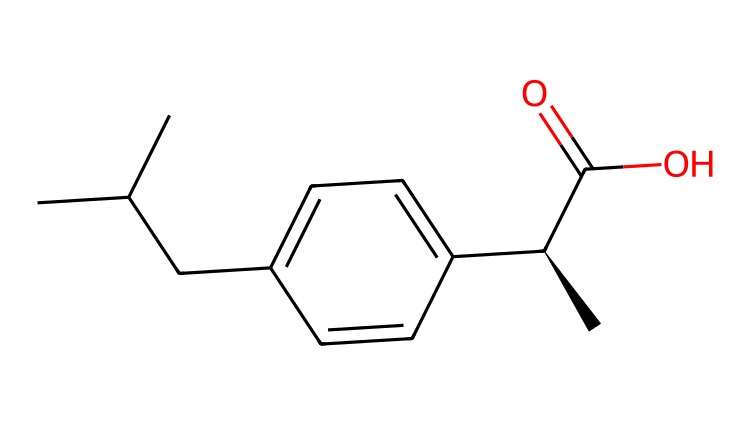What is the molecular formula of ibuprofen? By analyzing the SMILES representation (CC(C)Cc1ccc(cc1)[C@H](C)C(=O)O), we can count each type of atom present. The carbon (C) atoms can be identified as the backbone of the structure, along with oxygen (O) atoms that are present at the end of the structure. In total, there are 13 carbon atoms, 18 hydrogen atoms, and 2 oxygen atoms. Thus, the molecular formula can be assembled as C13H18O2.
Answer: C13H18O2 How many carbon atoms are present in ibuprofen? Observing the SMILES, we can see the chain and ring structures formed by the carbon atoms. By counting the occurrences of the letter 'C', we can identify there are 13 carbon atoms in the molecule.
Answer: 13 What type of functional group is present in ibuprofen? In the given SMILES, the portion "C(=O)O" denotes a carboxylic acid group. This part shows that there is a carbon atom double-bonded to an oxygen (C=O) and also bonded to a hydroxyl group (–OH), which defines the characteristic functional group of carboxylic acids.
Answer: carboxylic acid What is the stereochemistry feature of ibuprofen? The SMILES representation includes the symbol "[C@H]", which indicates that there is at least one chiral carbon in the structure. A chiral center allows for the existence of two enantiomers, which is a feature characteristic of the stereochemistry of the molecule.
Answer: chiral carbon What type of bond connects the carbon atoms in ibuprofen? In ibuprofen, the carbon atoms are primarily connected through single covalent bonds; however, there is also at least one double bond between a carbon and an oxygen atom (the carbonyl group). The predominant bond type is covalent for the carbon chain.
Answer: covalent bond What is the indicative structural feature of pain relief in ibuprofen? The presence of the carboxylic acid group ("C(=O)O") plays a significant role in the drug’s pharmacological effects related to pain relief, contributing to its anti-inflammatory properties through inhibition of cyclooxygenase enzymes.
Answer: carboxylic acid 